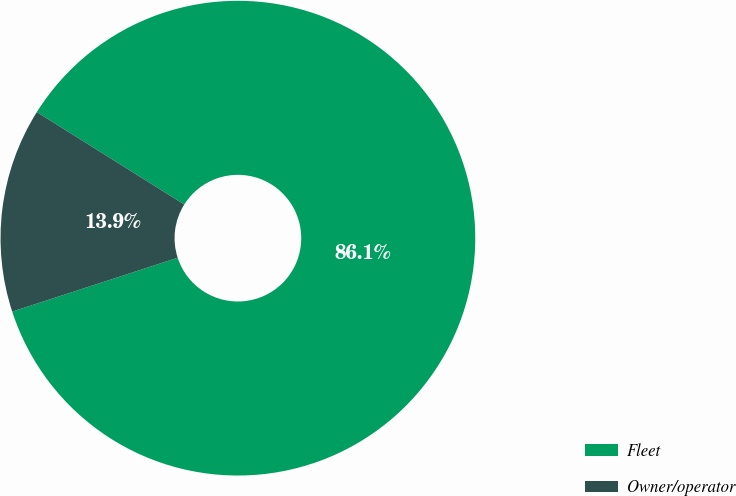<chart> <loc_0><loc_0><loc_500><loc_500><pie_chart><fcel>Fleet<fcel>Owner/operator<nl><fcel>86.08%<fcel>13.92%<nl></chart> 